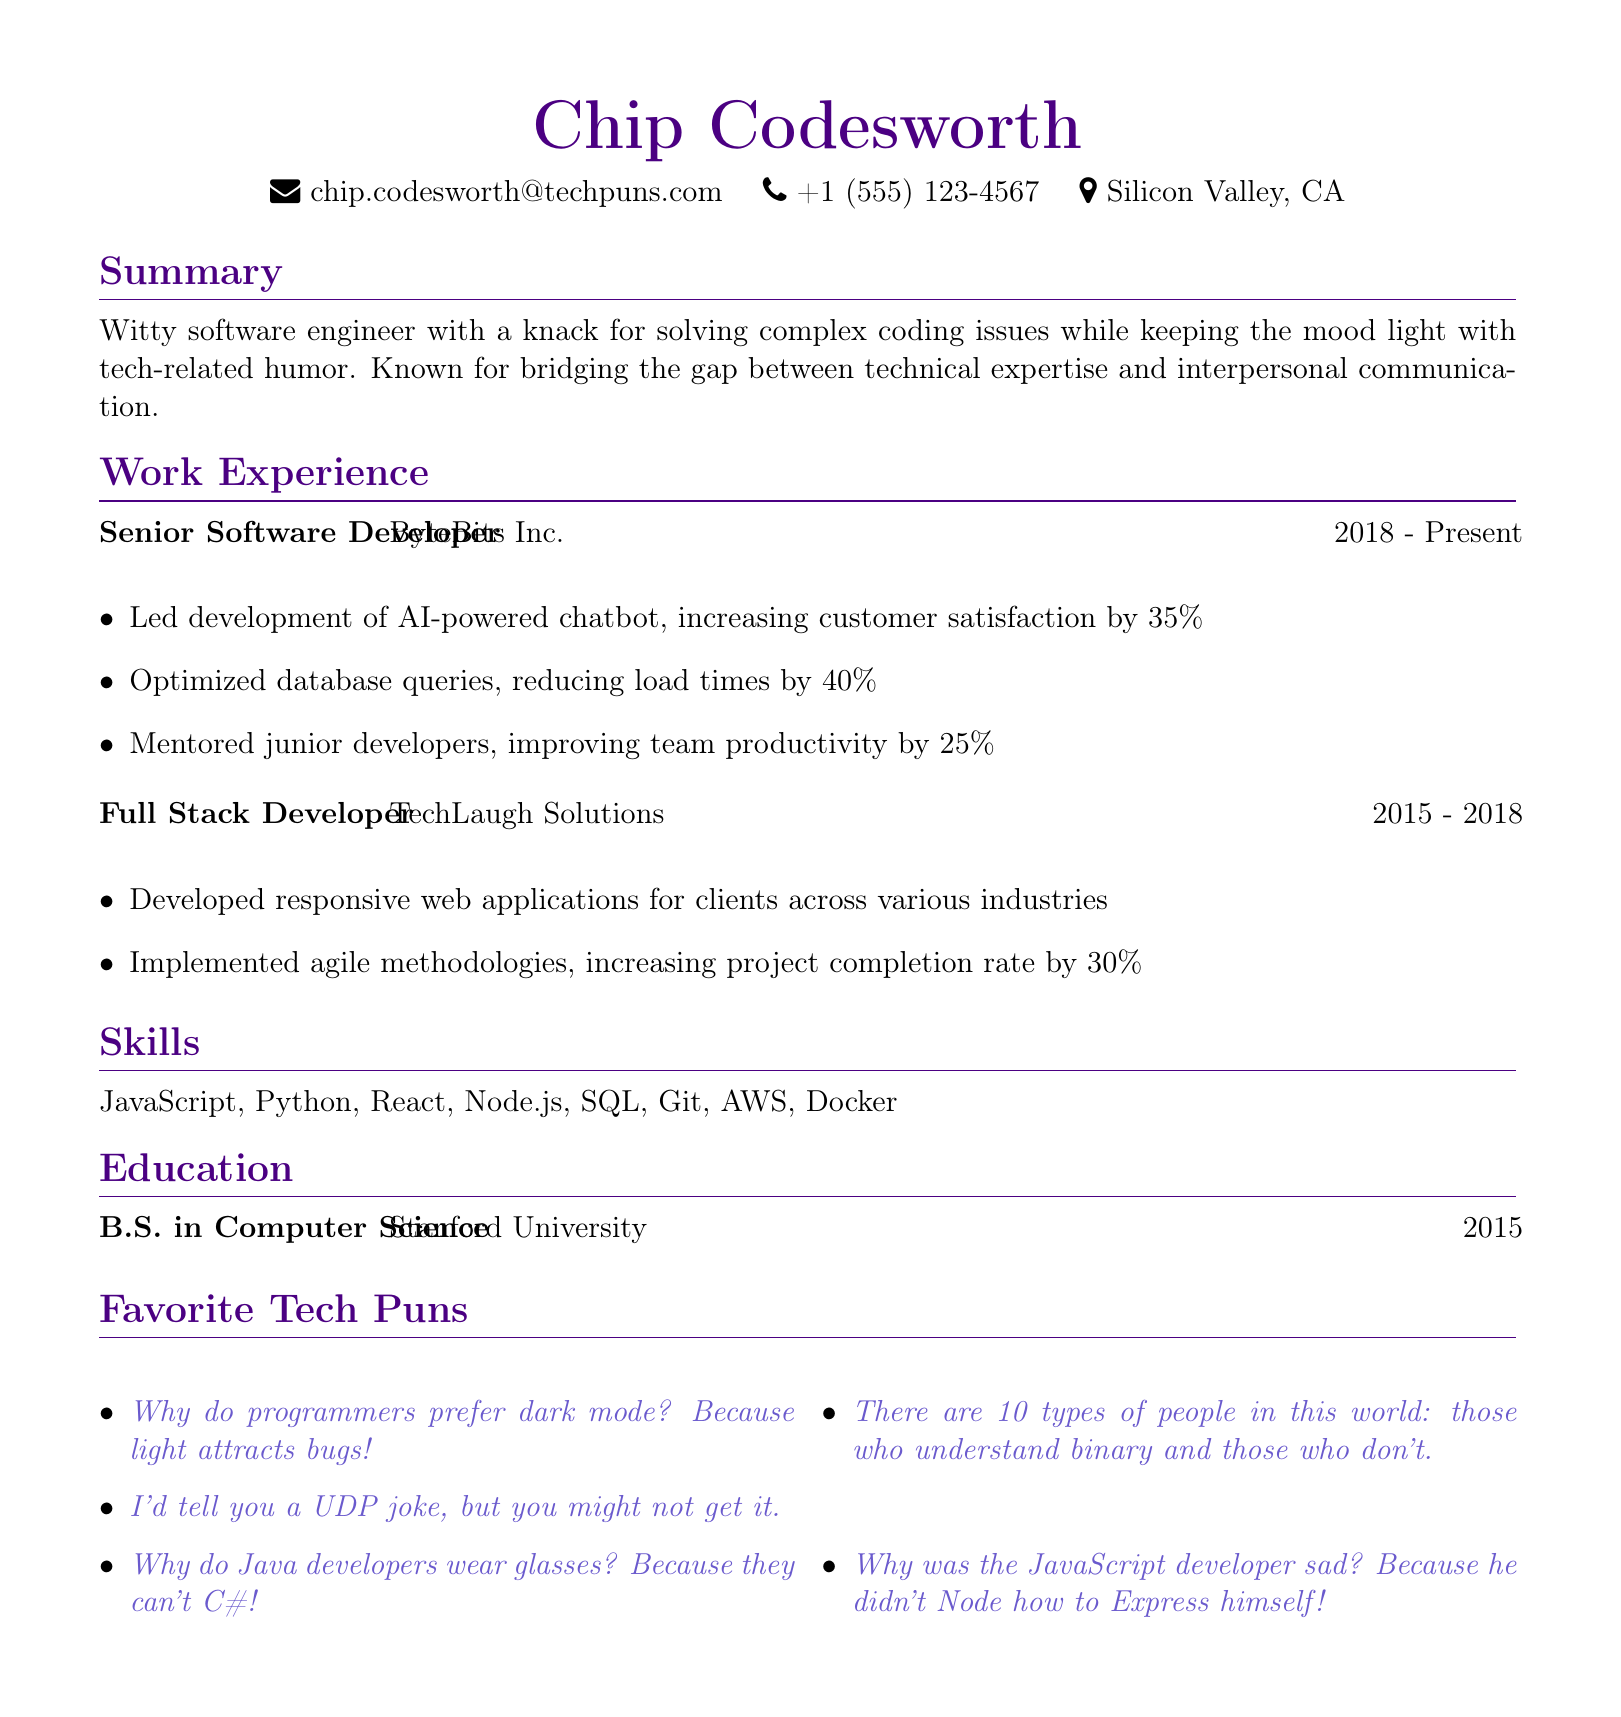What is the name of the individual? The name of the individual is presented in the header section of the CV.
Answer: Chip Codesworth What is Chip Codesworth's email address? The email address is provided in the personal information section.
Answer: chip.codesworth@techpuns.com How many years did Chip Codesworth work at ByteBits Inc.? The duration of employment at ByteBits Inc. is noted in the work experience section.
Answer: 5 years What was one of the achievements at ByteBits Inc.? Achievements are listed in bullet points under the respective job position.
Answer: Led development of AI-powered chatbot What degree did Chip Codesworth earn? The degree information is provided in the education section of the CV.
Answer: B.S. in Computer Science Which programming languages are listed as skills? Skills are detailed in their own section within the document.
Answer: JavaScript, Python, React, Node.js, SQL, Git, AWS, Docker What type of document is this? The structure and content indicate that it serves a specific purpose.
Answer: Curriculum Vitae How many tech puns are listed? The count is derived from the number of items in the favorite tech puns section.
Answer: 5 Why did the JavaScript developer feel sad? The answer is provided in one of the tech puns listed in the document.
Answer: Because he didn't Node how to Express himself! What company did Chip Codesworth work for before ByteBits Inc.? The prior employment is mentioned in the work experience section.
Answer: TechLaugh Solutions 